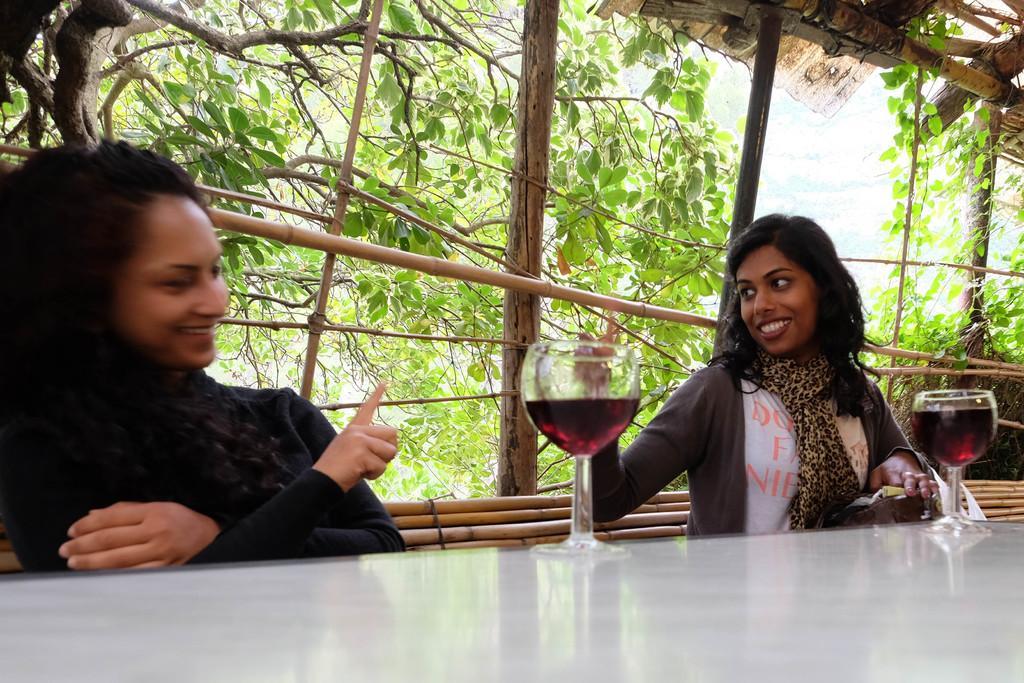Describe this image in one or two sentences. In this picture there are two women who are sitting in the chair. There are two glasses on the table. There is a red wine in the glasses. There are wooden sticks and some trees at the background. 